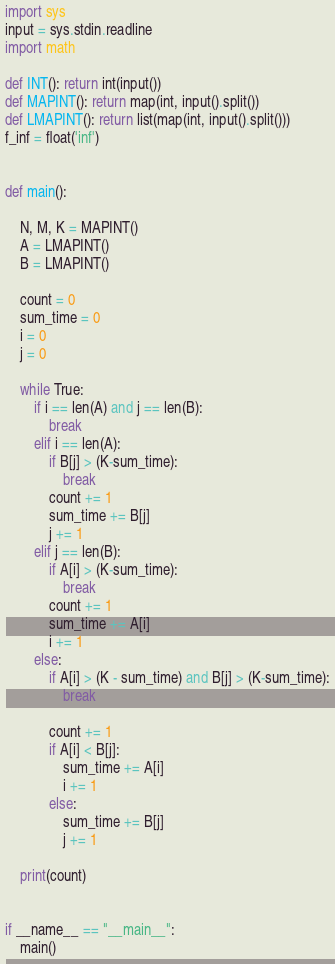<code> <loc_0><loc_0><loc_500><loc_500><_Cython_>import sys
input = sys.stdin.readline
import math

def INT(): return int(input())
def MAPINT(): return map(int, input().split())
def LMAPINT(): return list(map(int, input().split()))
f_inf = float('inf')


def main():

    N, M, K = MAPINT()
    A = LMAPINT()
    B = LMAPINT()

    count = 0
    sum_time = 0
    i = 0
    j = 0

    while True:
        if i == len(A) and j == len(B):
            break
        elif i == len(A):
            if B[j] > (K-sum_time):
                break
            count += 1
            sum_time += B[j]
            j += 1
        elif j == len(B):
            if A[i] > (K-sum_time):
                break
            count += 1
            sum_time += A[i]
            i += 1
        else:
            if A[i] > (K - sum_time) and B[j] > (K-sum_time):
                break

            count += 1
            if A[i] < B[j]:
                sum_time += A[i]
                i += 1
            else:
                sum_time += B[j]
                j += 1

    print(count)


if __name__ == "__main__":
    main()
</code> 